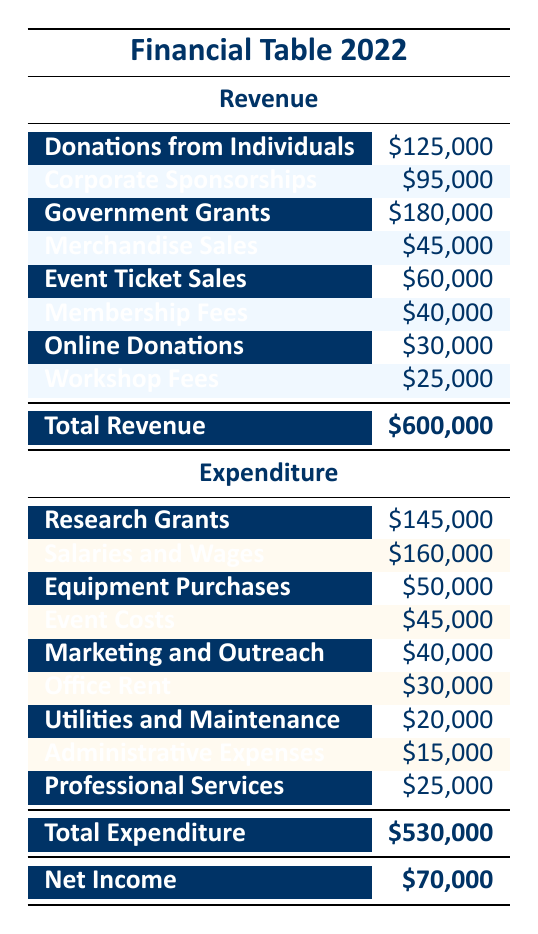What is the total revenue generated by the organization in 2022? The table states a "Total Revenue" of \$600,000, which includes all the sources of revenue summed together.
Answer: 600000 Which source of revenue received the highest amount? By examining the revenue section of the table, "Government Grants" has the highest amount listed at \$180,000.
Answer: 180000 What is the combined total for donations from individuals and online donations? To find this, sum the amounts for "Donations from Individuals" (\$125,000) and "Online Donations" (\$30,000): 125,000 + 30,000 = 155,000.
Answer: 155000 Did the organization spend more on salaries and wages than on research grants? The table shows "Salaries and Wages" at \$160,000 and "Research Grants" at \$145,000. Since 160,000 > 145,000, the statement is true.
Answer: Yes What is the net income of the organization after all expenditures? The table states a "Net Income" of \$70,000, which is calculated as total revenue (\$600,000) minus total expenditure (\$530,000).
Answer: 70000 What percentage of the total expenditure was spent on salaries and wages? To calculate the percentage, take the amount for "Salaries and Wages" (\$160,000) and divide it by the total expenditure (\$530,000), then multiply by 100: (160,000 / 530,000) * 100 ≈ 30.19%.
Answer: 30.19 If the organization were to increase "Event Costs" by 20%, what would be the new amount? The original "Event Costs" amount is \$45,000. Increasing it by 20% means calculating 20% of 45,000 (which is \$9,000) and adding that to the original amount: 45,000 + 9,000 = 54,000.
Answer: 54000 How much less was spent on administrative expenses compared to equipment purchases? The difference between "Equipment Purchases" (\$50,000) and "Administrative Expenses" (\$15,000) is found by subtracting: 50,000 - 15,000 = 35,000.
Answer: 35000 Which category had the second highest expenditure after salaries and wages? The table shows the amounts for "Salaries and Wages" (\$160,000) and then lists "Research Grants" (\$145,000) as the next highest category.
Answer: Research Grants 